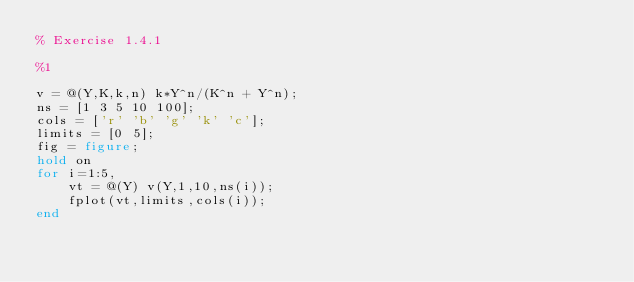Convert code to text. <code><loc_0><loc_0><loc_500><loc_500><_Matlab_>% Exercise 1.4.1

%1

v = @(Y,K,k,n) k*Y^n/(K^n + Y^n);
ns = [1 3 5 10 100]; 
cols = ['r' 'b' 'g' 'k' 'c'];
limits = [0 5];
fig = figure;
hold on
for i=1:5,
    vt = @(Y) v(Y,1,10,ns(i));
    fplot(vt,limits,cols(i));
end</code> 